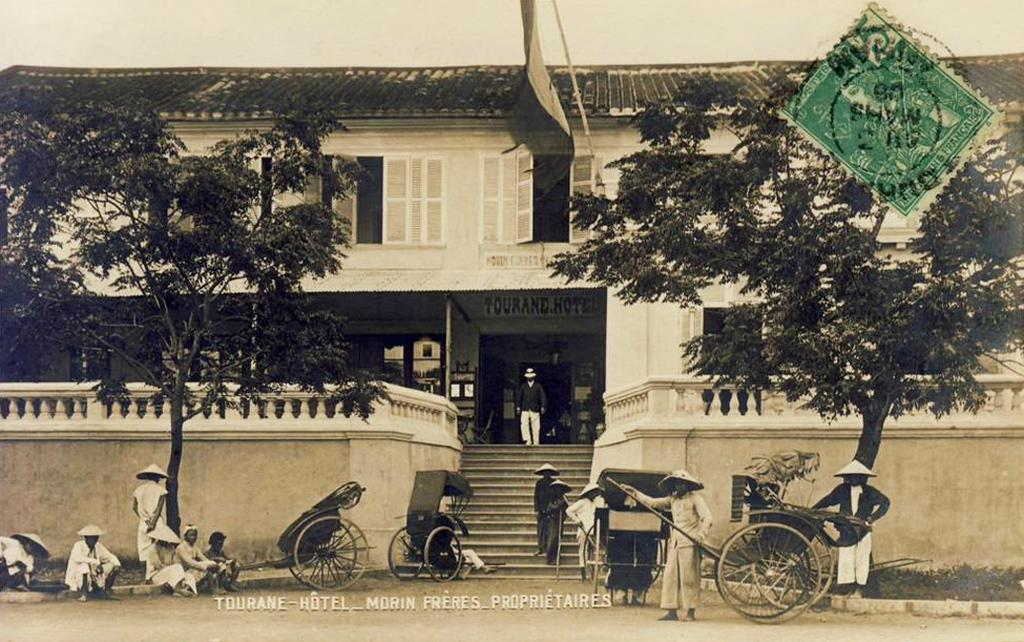How many people are in the group visible in the image? There is a group of people in the image, but the exact number cannot be determined from the provided facts. What objects are present in the image besides the people? There are carts, trees, a building, and a flag visible in the image. What is the background of the image? The background of the image includes a building and a flag. Is there any additional information about the image in the top right corner? Yes, there is a stamp in the top right corner of the image. What type of lettuce can be seen growing on the trees in the image? There is no lettuce visible in the image; the trees are not mentioned as having any specific type of vegetation. How many cats are sitting on the carts in the image? There are no cats present in the image; only people, carts, trees, a building, a flag, and a stamp are mentioned. 